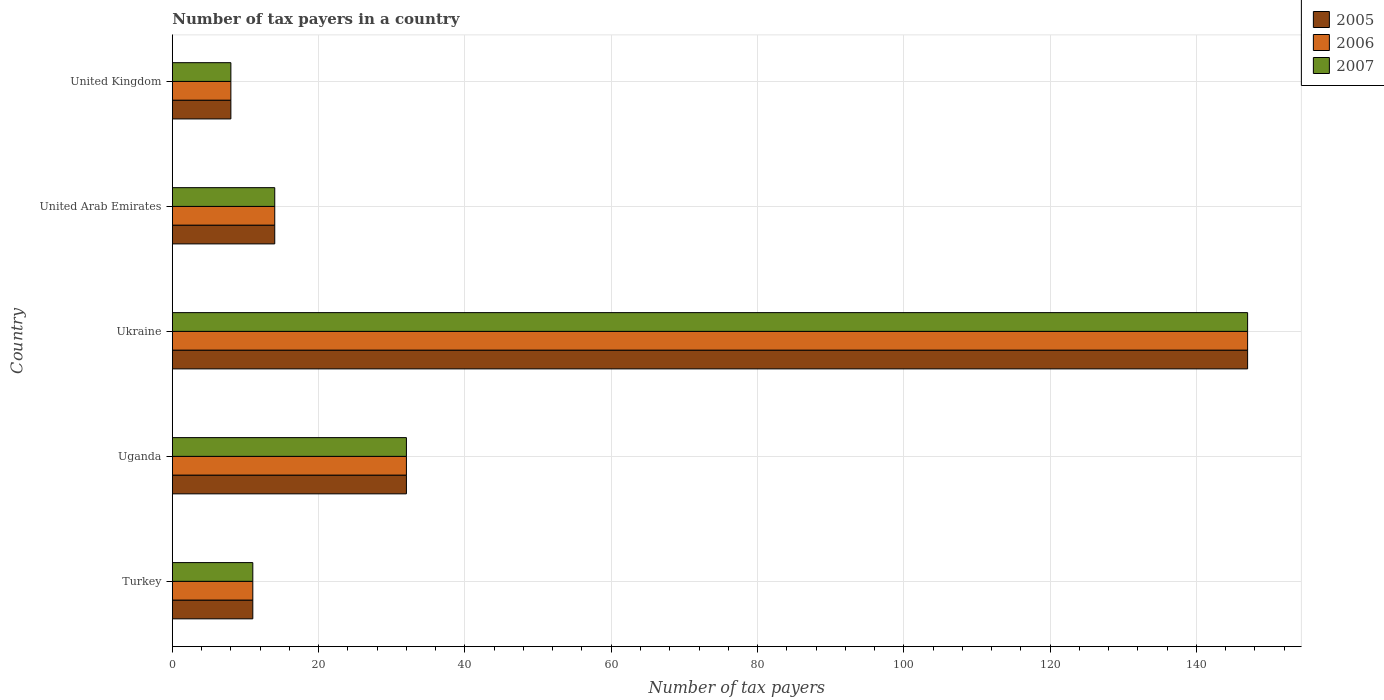How many different coloured bars are there?
Your answer should be compact. 3. How many groups of bars are there?
Give a very brief answer. 5. Are the number of bars per tick equal to the number of legend labels?
Your answer should be very brief. Yes. How many bars are there on the 4th tick from the bottom?
Ensure brevity in your answer.  3. What is the label of the 3rd group of bars from the top?
Give a very brief answer. Ukraine. In how many cases, is the number of bars for a given country not equal to the number of legend labels?
Your answer should be very brief. 0. What is the number of tax payers in in 2006 in Uganda?
Keep it short and to the point. 32. Across all countries, what is the maximum number of tax payers in in 2005?
Give a very brief answer. 147. In which country was the number of tax payers in in 2006 maximum?
Offer a terse response. Ukraine. In which country was the number of tax payers in in 2005 minimum?
Ensure brevity in your answer.  United Kingdom. What is the total number of tax payers in in 2005 in the graph?
Your answer should be compact. 212. What is the difference between the number of tax payers in in 2005 in United Arab Emirates and that in United Kingdom?
Offer a very short reply. 6. What is the difference between the number of tax payers in in 2006 in Uganda and the number of tax payers in in 2007 in Ukraine?
Provide a short and direct response. -115. What is the average number of tax payers in in 2005 per country?
Ensure brevity in your answer.  42.4. In how many countries, is the number of tax payers in in 2007 greater than 48 ?
Offer a terse response. 1. What is the ratio of the number of tax payers in in 2007 in Turkey to that in Uganda?
Your answer should be compact. 0.34. What is the difference between the highest and the second highest number of tax payers in in 2006?
Ensure brevity in your answer.  115. What is the difference between the highest and the lowest number of tax payers in in 2006?
Your answer should be compact. 139. Is the sum of the number of tax payers in in 2007 in Uganda and Ukraine greater than the maximum number of tax payers in in 2005 across all countries?
Your answer should be compact. Yes. What does the 1st bar from the top in Turkey represents?
Your answer should be compact. 2007. Are the values on the major ticks of X-axis written in scientific E-notation?
Make the answer very short. No. Does the graph contain any zero values?
Provide a short and direct response. No. How many legend labels are there?
Your answer should be very brief. 3. What is the title of the graph?
Ensure brevity in your answer.  Number of tax payers in a country. What is the label or title of the X-axis?
Provide a succinct answer. Number of tax payers. What is the Number of tax payers in 2007 in Turkey?
Provide a succinct answer. 11. What is the Number of tax payers in 2005 in Uganda?
Your response must be concise. 32. What is the Number of tax payers in 2005 in Ukraine?
Give a very brief answer. 147. What is the Number of tax payers in 2006 in Ukraine?
Keep it short and to the point. 147. What is the Number of tax payers in 2007 in Ukraine?
Provide a succinct answer. 147. What is the Number of tax payers in 2005 in United Arab Emirates?
Provide a succinct answer. 14. What is the Number of tax payers of 2006 in United Arab Emirates?
Provide a succinct answer. 14. What is the Number of tax payers in 2007 in United Arab Emirates?
Provide a short and direct response. 14. What is the Number of tax payers in 2005 in United Kingdom?
Provide a succinct answer. 8. What is the Number of tax payers in 2006 in United Kingdom?
Your response must be concise. 8. Across all countries, what is the maximum Number of tax payers of 2005?
Keep it short and to the point. 147. Across all countries, what is the maximum Number of tax payers of 2006?
Keep it short and to the point. 147. Across all countries, what is the maximum Number of tax payers in 2007?
Offer a very short reply. 147. Across all countries, what is the minimum Number of tax payers in 2005?
Provide a short and direct response. 8. Across all countries, what is the minimum Number of tax payers in 2006?
Your answer should be very brief. 8. Across all countries, what is the minimum Number of tax payers of 2007?
Your answer should be very brief. 8. What is the total Number of tax payers of 2005 in the graph?
Offer a very short reply. 212. What is the total Number of tax payers of 2006 in the graph?
Make the answer very short. 212. What is the total Number of tax payers in 2007 in the graph?
Offer a very short reply. 212. What is the difference between the Number of tax payers of 2005 in Turkey and that in Uganda?
Offer a terse response. -21. What is the difference between the Number of tax payers of 2006 in Turkey and that in Uganda?
Your response must be concise. -21. What is the difference between the Number of tax payers in 2007 in Turkey and that in Uganda?
Your answer should be compact. -21. What is the difference between the Number of tax payers of 2005 in Turkey and that in Ukraine?
Keep it short and to the point. -136. What is the difference between the Number of tax payers in 2006 in Turkey and that in Ukraine?
Give a very brief answer. -136. What is the difference between the Number of tax payers in 2007 in Turkey and that in Ukraine?
Offer a very short reply. -136. What is the difference between the Number of tax payers in 2006 in Turkey and that in United Arab Emirates?
Keep it short and to the point. -3. What is the difference between the Number of tax payers in 2005 in Uganda and that in Ukraine?
Your answer should be very brief. -115. What is the difference between the Number of tax payers in 2006 in Uganda and that in Ukraine?
Your response must be concise. -115. What is the difference between the Number of tax payers of 2007 in Uganda and that in Ukraine?
Provide a short and direct response. -115. What is the difference between the Number of tax payers of 2006 in Uganda and that in United Arab Emirates?
Make the answer very short. 18. What is the difference between the Number of tax payers of 2006 in Uganda and that in United Kingdom?
Ensure brevity in your answer.  24. What is the difference between the Number of tax payers in 2005 in Ukraine and that in United Arab Emirates?
Offer a very short reply. 133. What is the difference between the Number of tax payers in 2006 in Ukraine and that in United Arab Emirates?
Provide a short and direct response. 133. What is the difference between the Number of tax payers in 2007 in Ukraine and that in United Arab Emirates?
Your answer should be compact. 133. What is the difference between the Number of tax payers in 2005 in Ukraine and that in United Kingdom?
Your response must be concise. 139. What is the difference between the Number of tax payers of 2006 in Ukraine and that in United Kingdom?
Your answer should be compact. 139. What is the difference between the Number of tax payers of 2007 in Ukraine and that in United Kingdom?
Make the answer very short. 139. What is the difference between the Number of tax payers in 2005 in Turkey and the Number of tax payers in 2006 in Uganda?
Your answer should be compact. -21. What is the difference between the Number of tax payers of 2005 in Turkey and the Number of tax payers of 2007 in Uganda?
Provide a succinct answer. -21. What is the difference between the Number of tax payers in 2006 in Turkey and the Number of tax payers in 2007 in Uganda?
Your response must be concise. -21. What is the difference between the Number of tax payers of 2005 in Turkey and the Number of tax payers of 2006 in Ukraine?
Your response must be concise. -136. What is the difference between the Number of tax payers in 2005 in Turkey and the Number of tax payers in 2007 in Ukraine?
Provide a short and direct response. -136. What is the difference between the Number of tax payers of 2006 in Turkey and the Number of tax payers of 2007 in Ukraine?
Make the answer very short. -136. What is the difference between the Number of tax payers in 2005 in Turkey and the Number of tax payers in 2006 in United Arab Emirates?
Ensure brevity in your answer.  -3. What is the difference between the Number of tax payers in 2006 in Turkey and the Number of tax payers in 2007 in United Arab Emirates?
Provide a short and direct response. -3. What is the difference between the Number of tax payers of 2005 in Turkey and the Number of tax payers of 2007 in United Kingdom?
Give a very brief answer. 3. What is the difference between the Number of tax payers in 2005 in Uganda and the Number of tax payers in 2006 in Ukraine?
Offer a terse response. -115. What is the difference between the Number of tax payers of 2005 in Uganda and the Number of tax payers of 2007 in Ukraine?
Offer a very short reply. -115. What is the difference between the Number of tax payers of 2006 in Uganda and the Number of tax payers of 2007 in Ukraine?
Provide a short and direct response. -115. What is the difference between the Number of tax payers in 2005 in Uganda and the Number of tax payers in 2006 in United Arab Emirates?
Your answer should be very brief. 18. What is the difference between the Number of tax payers in 2006 in Uganda and the Number of tax payers in 2007 in United Arab Emirates?
Ensure brevity in your answer.  18. What is the difference between the Number of tax payers of 2005 in Uganda and the Number of tax payers of 2007 in United Kingdom?
Keep it short and to the point. 24. What is the difference between the Number of tax payers of 2006 in Uganda and the Number of tax payers of 2007 in United Kingdom?
Your answer should be very brief. 24. What is the difference between the Number of tax payers of 2005 in Ukraine and the Number of tax payers of 2006 in United Arab Emirates?
Ensure brevity in your answer.  133. What is the difference between the Number of tax payers of 2005 in Ukraine and the Number of tax payers of 2007 in United Arab Emirates?
Your answer should be very brief. 133. What is the difference between the Number of tax payers of 2006 in Ukraine and the Number of tax payers of 2007 in United Arab Emirates?
Give a very brief answer. 133. What is the difference between the Number of tax payers in 2005 in Ukraine and the Number of tax payers in 2006 in United Kingdom?
Your answer should be compact. 139. What is the difference between the Number of tax payers in 2005 in Ukraine and the Number of tax payers in 2007 in United Kingdom?
Give a very brief answer. 139. What is the difference between the Number of tax payers in 2006 in Ukraine and the Number of tax payers in 2007 in United Kingdom?
Give a very brief answer. 139. What is the average Number of tax payers of 2005 per country?
Give a very brief answer. 42.4. What is the average Number of tax payers in 2006 per country?
Ensure brevity in your answer.  42.4. What is the average Number of tax payers in 2007 per country?
Your answer should be compact. 42.4. What is the difference between the Number of tax payers in 2005 and Number of tax payers in 2007 in Turkey?
Your answer should be compact. 0. What is the difference between the Number of tax payers of 2005 and Number of tax payers of 2006 in Ukraine?
Make the answer very short. 0. What is the difference between the Number of tax payers of 2005 and Number of tax payers of 2007 in Ukraine?
Offer a terse response. 0. What is the difference between the Number of tax payers in 2005 and Number of tax payers in 2006 in United Kingdom?
Keep it short and to the point. 0. What is the ratio of the Number of tax payers in 2005 in Turkey to that in Uganda?
Your answer should be very brief. 0.34. What is the ratio of the Number of tax payers in 2006 in Turkey to that in Uganda?
Give a very brief answer. 0.34. What is the ratio of the Number of tax payers of 2007 in Turkey to that in Uganda?
Ensure brevity in your answer.  0.34. What is the ratio of the Number of tax payers in 2005 in Turkey to that in Ukraine?
Give a very brief answer. 0.07. What is the ratio of the Number of tax payers of 2006 in Turkey to that in Ukraine?
Your response must be concise. 0.07. What is the ratio of the Number of tax payers of 2007 in Turkey to that in Ukraine?
Provide a short and direct response. 0.07. What is the ratio of the Number of tax payers of 2005 in Turkey to that in United Arab Emirates?
Your answer should be compact. 0.79. What is the ratio of the Number of tax payers in 2006 in Turkey to that in United Arab Emirates?
Provide a short and direct response. 0.79. What is the ratio of the Number of tax payers in 2007 in Turkey to that in United Arab Emirates?
Keep it short and to the point. 0.79. What is the ratio of the Number of tax payers of 2005 in Turkey to that in United Kingdom?
Your answer should be compact. 1.38. What is the ratio of the Number of tax payers of 2006 in Turkey to that in United Kingdom?
Offer a very short reply. 1.38. What is the ratio of the Number of tax payers in 2007 in Turkey to that in United Kingdom?
Your answer should be very brief. 1.38. What is the ratio of the Number of tax payers in 2005 in Uganda to that in Ukraine?
Provide a succinct answer. 0.22. What is the ratio of the Number of tax payers in 2006 in Uganda to that in Ukraine?
Ensure brevity in your answer.  0.22. What is the ratio of the Number of tax payers in 2007 in Uganda to that in Ukraine?
Your response must be concise. 0.22. What is the ratio of the Number of tax payers of 2005 in Uganda to that in United Arab Emirates?
Keep it short and to the point. 2.29. What is the ratio of the Number of tax payers of 2006 in Uganda to that in United Arab Emirates?
Make the answer very short. 2.29. What is the ratio of the Number of tax payers in 2007 in Uganda to that in United Arab Emirates?
Provide a short and direct response. 2.29. What is the ratio of the Number of tax payers of 2005 in Uganda to that in United Kingdom?
Offer a very short reply. 4. What is the ratio of the Number of tax payers of 2006 in Uganda to that in United Kingdom?
Offer a very short reply. 4. What is the ratio of the Number of tax payers of 2006 in Ukraine to that in United Arab Emirates?
Give a very brief answer. 10.5. What is the ratio of the Number of tax payers of 2005 in Ukraine to that in United Kingdom?
Provide a short and direct response. 18.38. What is the ratio of the Number of tax payers in 2006 in Ukraine to that in United Kingdom?
Your answer should be compact. 18.38. What is the ratio of the Number of tax payers in 2007 in Ukraine to that in United Kingdom?
Provide a succinct answer. 18.38. What is the ratio of the Number of tax payers in 2005 in United Arab Emirates to that in United Kingdom?
Offer a very short reply. 1.75. What is the ratio of the Number of tax payers in 2006 in United Arab Emirates to that in United Kingdom?
Your answer should be very brief. 1.75. What is the difference between the highest and the second highest Number of tax payers in 2005?
Keep it short and to the point. 115. What is the difference between the highest and the second highest Number of tax payers in 2006?
Offer a terse response. 115. What is the difference between the highest and the second highest Number of tax payers of 2007?
Make the answer very short. 115. What is the difference between the highest and the lowest Number of tax payers in 2005?
Offer a terse response. 139. What is the difference between the highest and the lowest Number of tax payers of 2006?
Give a very brief answer. 139. What is the difference between the highest and the lowest Number of tax payers of 2007?
Keep it short and to the point. 139. 